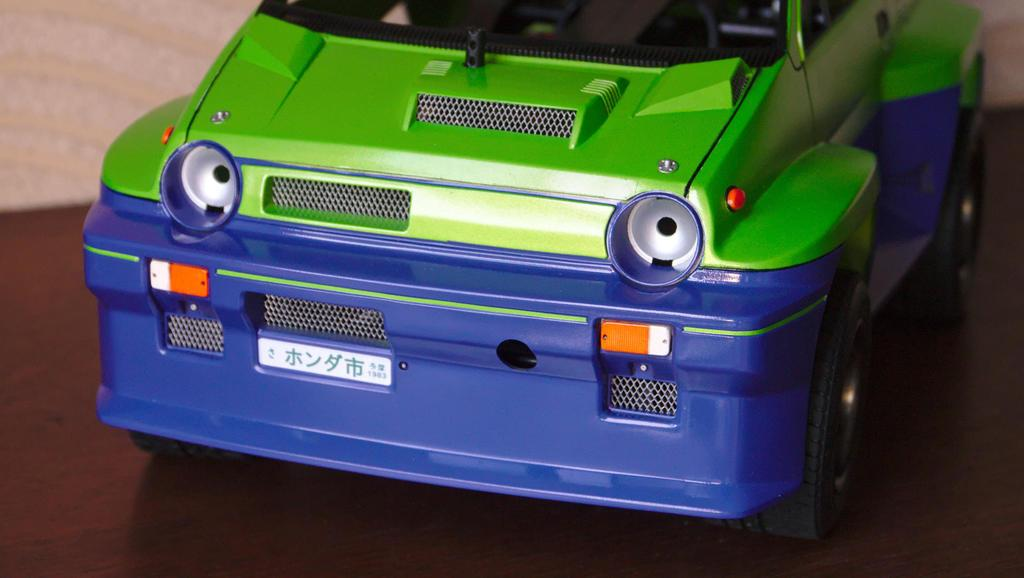What is the main object in the image? There is a toy car in the image. What colors are used for the toy car? The toy car is green and blue in color. Where is the toy car placed in the image? The toy car is placed on a wooden table top. What type of toothpaste is being used to paint the toy car in the image? There is no toothpaste present in the image, nor is the toy car being painted. 